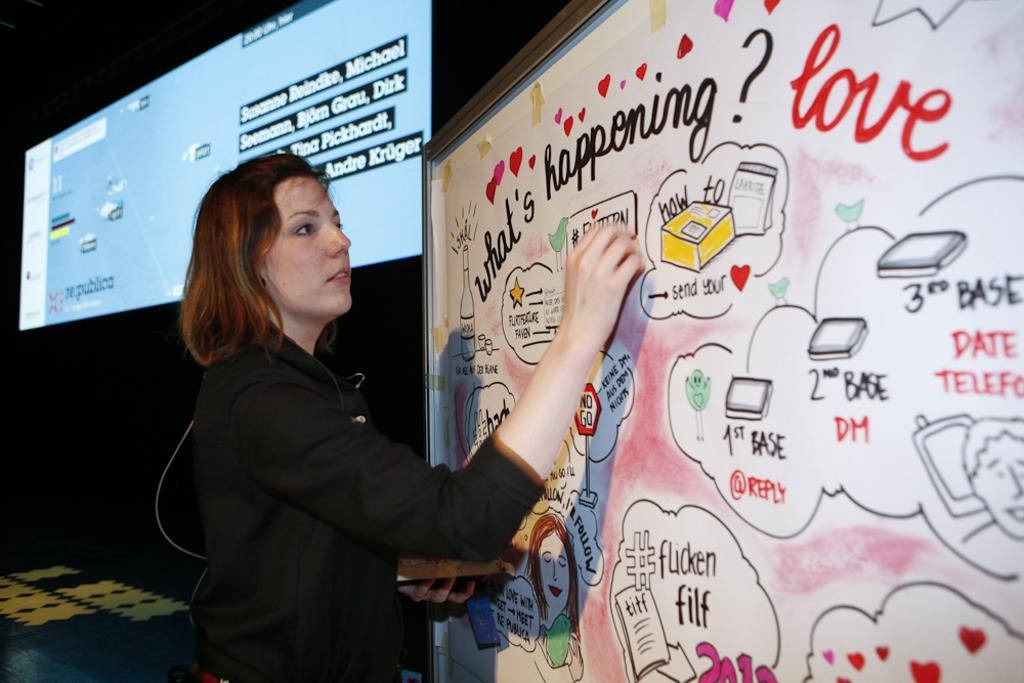<image>
Present a compact description of the photo's key features. Woman that is on a board and is writing and looking at different photos that say What;s Happening? love. 